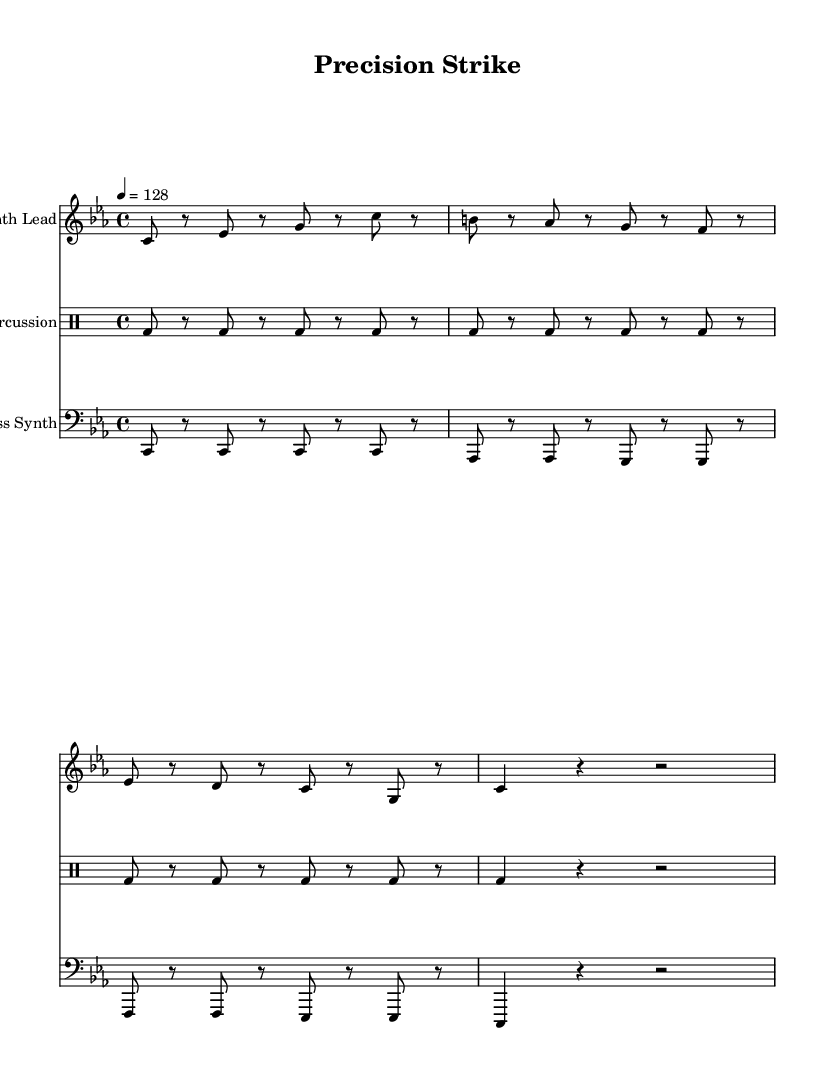What is the key signature of this music? The key signature is C minor, which has three flats (B flat, E flat, and A flat). This can be identified by looking at the key signature indicated at the beginning of the staff.
Answer: C minor What is the time signature of this piece? The time signature is 4/4, which means there are four beats in each measure and a quarter note gets one beat. This is indicated at the start of the piece.
Answer: 4/4 What is the tempo marking of the music? The tempo marking is 128 beats per minute, indicated by "4 = 128" at the beginning of the score, which suggests a moderately fast pace.
Answer: 128 How many measures are in the synth lead section? The synth lead section contains 8 measures, as denoted by the bar lines separating each measure in the staff.
Answer: 8 What type of sound does the bass synth play in this composition? The bass synth plays a sustained sound with longer notes, contrasting with the percussion's quickly played staccato beats, creating a fuller texture combined with rhythmic precision.
Answer: Sustained sound Which percussion instrument is predominantly used in this piece? The dominant percussion instrument is the bass drum, indicated by "bd" in the drummode section, which plays consistently throughout the measures.
Answer: Bass drum How does the rhythm in the percussion section contribute to the overall feel of the track? The rhythmic structure in the percussion section features staccato beats that mimic gunshots, which create an energetic and driving feel, enhancing the electronic pop style.
Answer: Staccato beats 